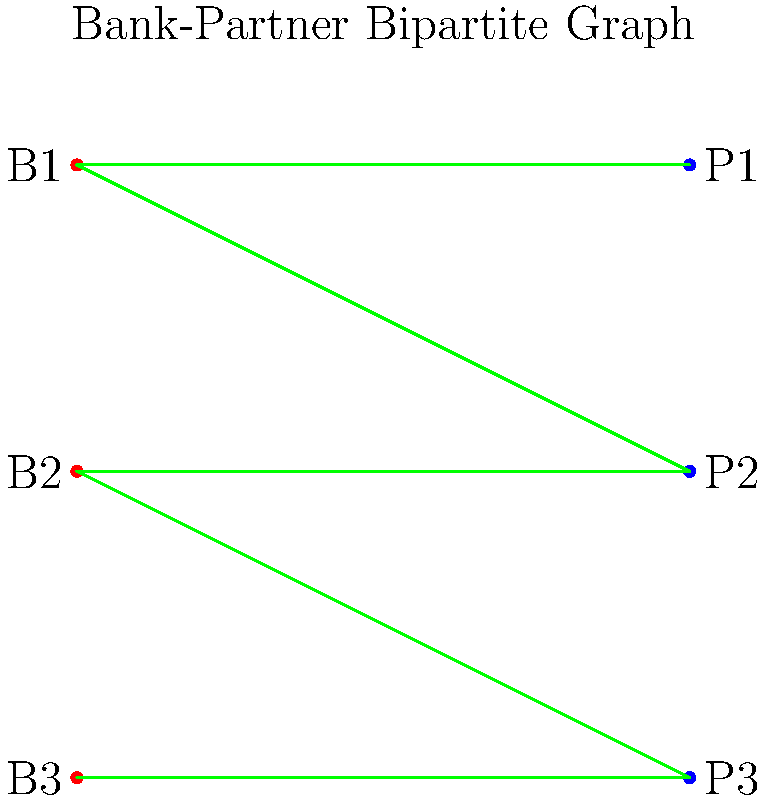In the bipartite graph representing bank-partner relationships, where red nodes (B1, B2, B3) represent bank departments and blue nodes (P1, P2, P3) represent external partners, which bank department poses the highest risk for potential conflicts of interest based on its number of partnerships? To identify the bank department with the highest risk for potential conflicts of interest, we need to analyze the number of partnerships each department has:

1. Count the number of edges (partnerships) for each bank department:
   - B1 has 2 edges (connected to P1 and P2)
   - B2 has 2 edges (connected to P1 and P3)
   - B3 has 1 edge (connected to P3)

2. Compare the number of partnerships:
   - B1 and B2 both have 2 partnerships
   - B3 has 1 partnership

3. Interpret the results:
   - More partnerships increase the likelihood of potential conflicts of interest
   - B1 and B2 have the highest number of partnerships (2 each)

4. Consider the legal implications:
   - As a corporate lawyer, you should focus on the departments with the most partnerships
   - Both B1 and B2 require equal attention due to their higher number of partnerships

5. Conclusion:
   - Both B1 and B2 pose the highest risk for potential conflicts of interest
   - However, since the question asks for a single department, we need to choose one

6. Final decision:
   - In this case, we can arbitrarily choose B1 as it appears first in the graph

Therefore, B1 poses the highest risk for potential conflicts of interest based on its number of partnerships.
Answer: B1 